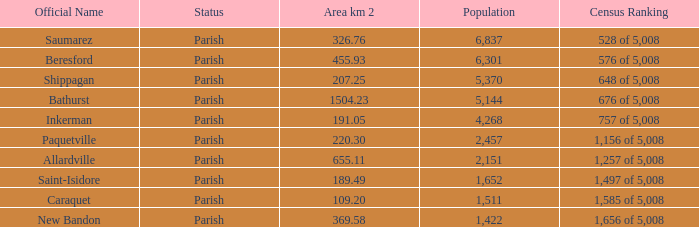What is the Population of the New Bandon Parish with an Area km 2 larger than 326.76? 1422.0. 